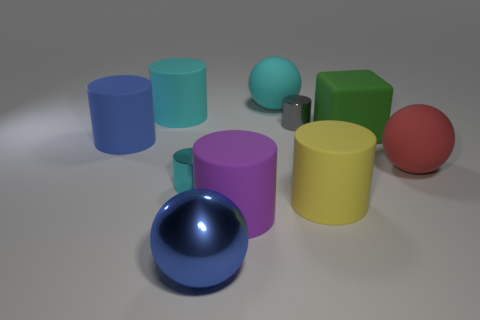There is a yellow cylinder that is the same size as the purple matte cylinder; what is its material?
Offer a terse response. Rubber. What number of other things are the same material as the large yellow cylinder?
Your answer should be very brief. 6. Do the cyan sphere and the blue object in front of the purple matte thing have the same size?
Make the answer very short. Yes. Is the number of blue cylinders in front of the small cyan shiny cylinder less than the number of cylinders that are left of the large blue sphere?
Provide a short and direct response. Yes. There is a matte ball in front of the green object; what size is it?
Offer a very short reply. Large. Does the purple matte cylinder have the same size as the cyan ball?
Give a very brief answer. Yes. How many small metal things are both in front of the large blue matte cylinder and behind the red rubber sphere?
Make the answer very short. 0. What number of cyan things are either matte balls or small shiny things?
Offer a very short reply. 2. How many matte objects are blue cylinders or tiny blue cylinders?
Give a very brief answer. 1. Is there a yellow metal cylinder?
Offer a very short reply. No. 